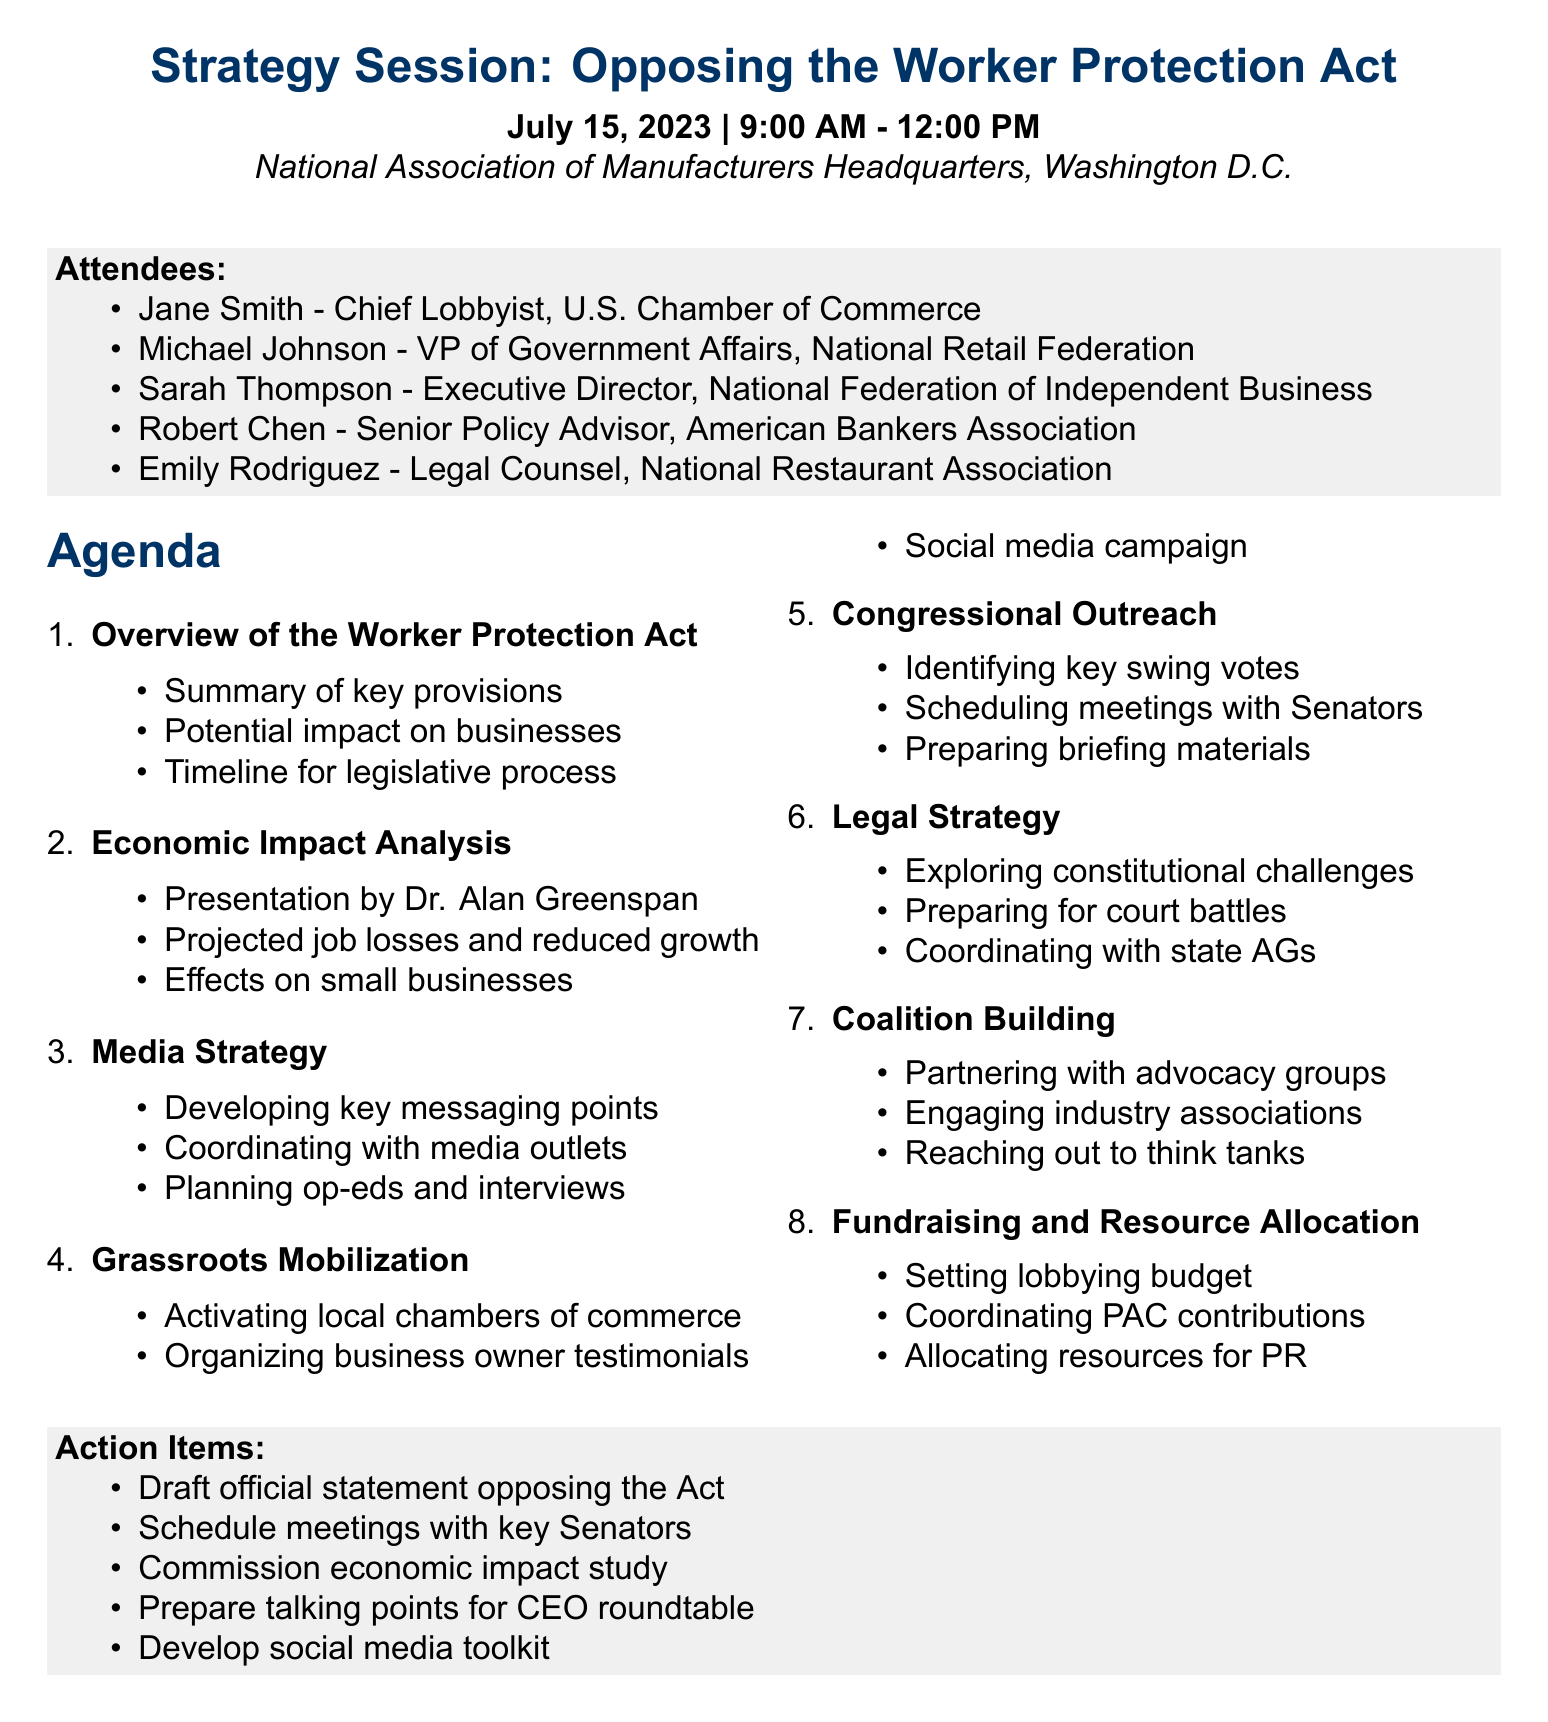What is the title of the meeting? The title of the meeting is presented at the top of the agenda, indicating its purpose.
Answer: Strategy Session: Opposing the Worker Protection Act Who is the Chief Lobbyist attending the meeting? The attendees section lists the names and titles of individuals present, identifying the Chief Lobbyist.
Answer: Jane Smith What is the date of the meeting? The date is specified in the meeting details section at the beginning of the document.
Answer: July 15, 2023 How long is the meeting scheduled to last? The duration of the meeting can be calculated from the start and end times mentioned in the meeting details.
Answer: 3 hours What is one of the action items listed? The action items are outlined at the end of the agenda, which includes specific tasks to be completed after the meeting.
Answer: Draft official statement opposing the Worker Protection Act What topic includes discussing key messaging points? The agenda item discusses strategies for communication and engagement, focusing on media relations.
Answer: Media Strategy Which individual is presenting the economic impact analysis? The document specifies who will provide the economic impact analysis, providing insights into the meeting's content.
Answer: Dr. Alan Greenspan What is one way to mobilize grassroots support mentioned in the agenda? Grassroots mobilization strategies are listed in an agenda item focused on local engagement and community involvement.
Answer: Activating local chambers of commerce 